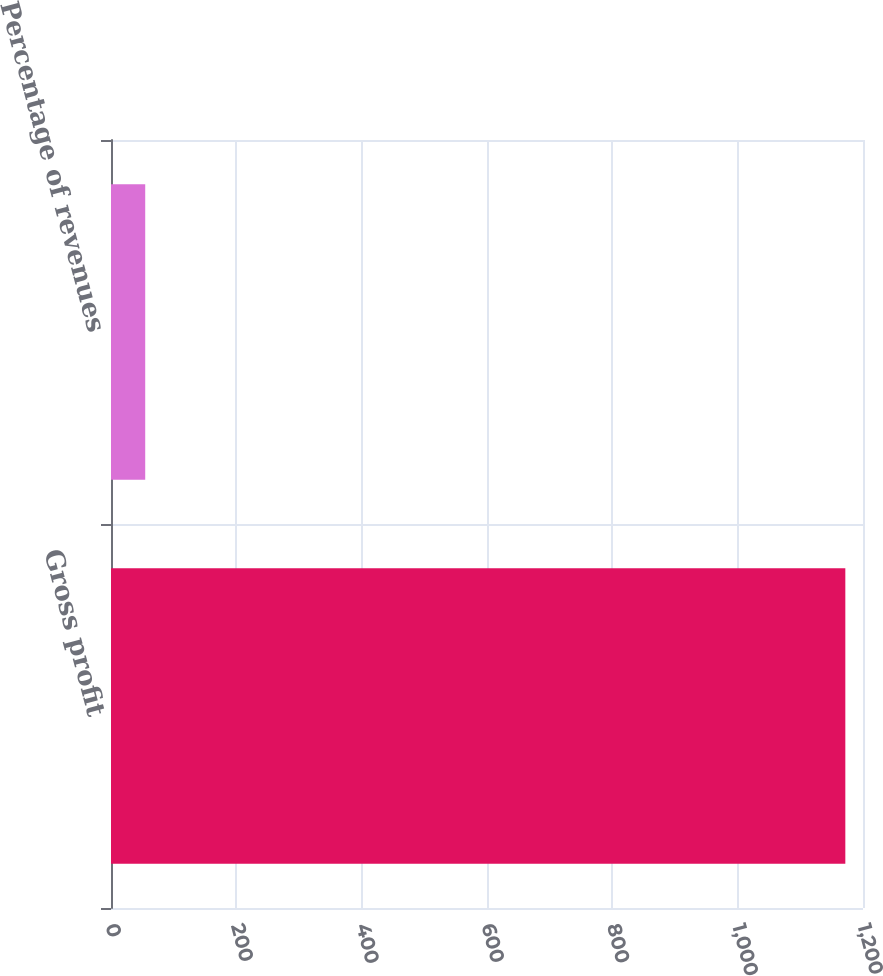<chart> <loc_0><loc_0><loc_500><loc_500><bar_chart><fcel>Gross profit<fcel>Percentage of revenues<nl><fcel>1171.8<fcel>54.6<nl></chart> 